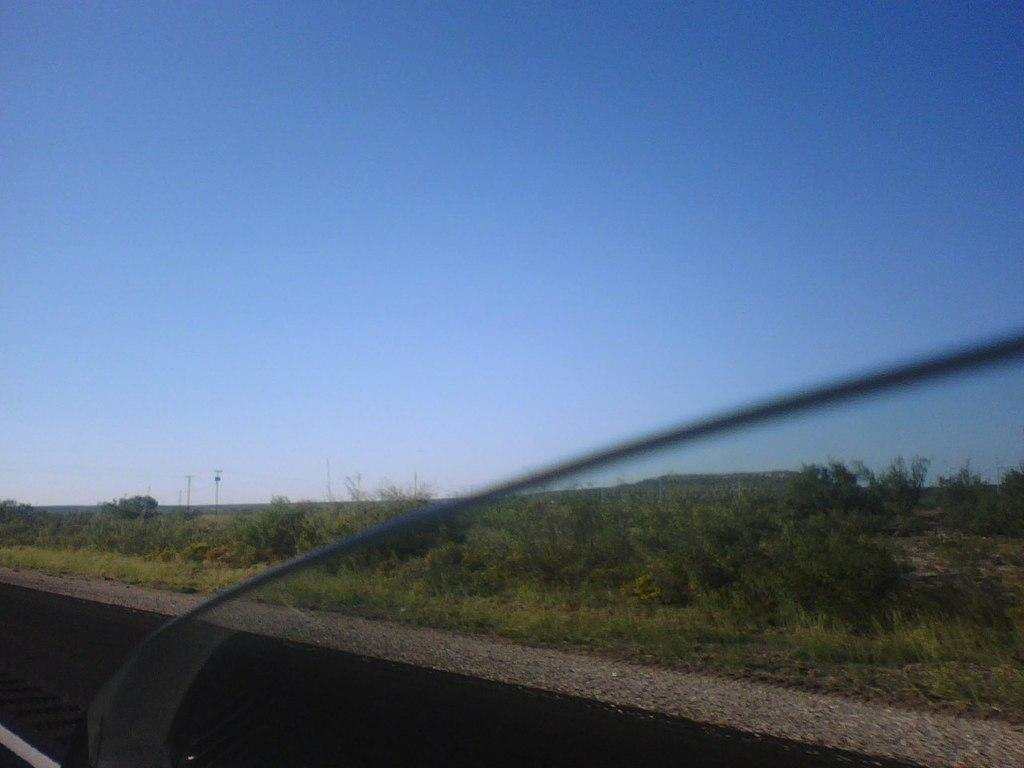What type of living organisms can be seen in the image? Plants and trees are visible in the image. What structures are present in the image? There are poles in the image. What part of the natural environment is visible in the image? The sky is visible in the background of the image. How does the sea affect the plants in the image? There is no sea present in the image, so it cannot be determined how the sea might affect the plants. What type of lift is used to transport the trees in the image? There is no lift present in the image, and the trees are stationary. 